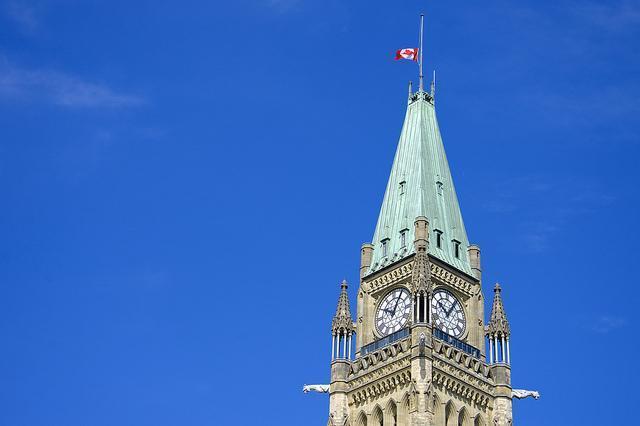How many people can be seen?
Give a very brief answer. 0. 